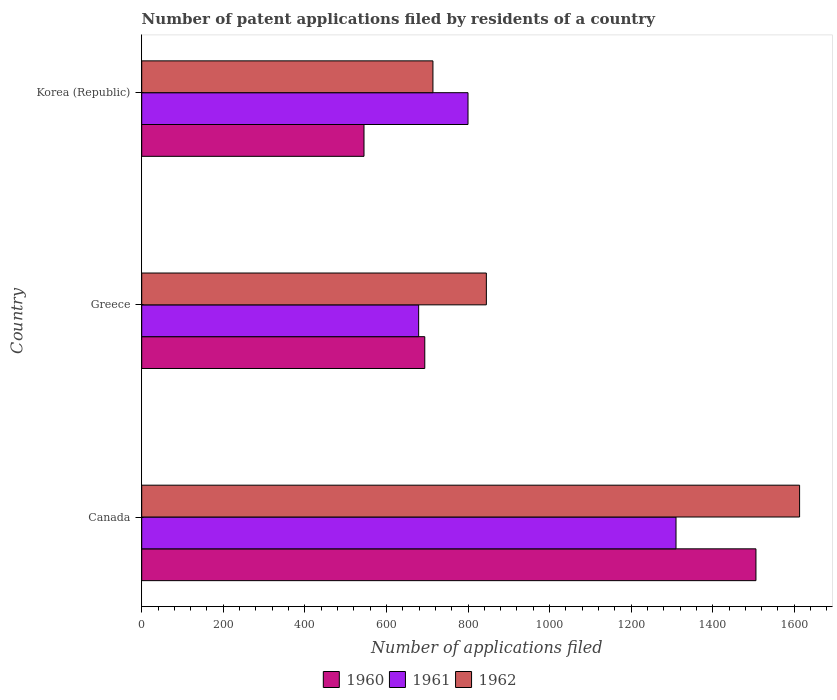How many different coloured bars are there?
Give a very brief answer. 3. How many groups of bars are there?
Your answer should be very brief. 3. Are the number of bars on each tick of the Y-axis equal?
Ensure brevity in your answer.  Yes. How many bars are there on the 2nd tick from the top?
Ensure brevity in your answer.  3. How many bars are there on the 1st tick from the bottom?
Offer a terse response. 3. What is the label of the 3rd group of bars from the top?
Your answer should be compact. Canada. What is the number of applications filed in 1962 in Greece?
Your answer should be very brief. 845. Across all countries, what is the maximum number of applications filed in 1962?
Your response must be concise. 1613. Across all countries, what is the minimum number of applications filed in 1962?
Ensure brevity in your answer.  714. In which country was the number of applications filed in 1960 minimum?
Ensure brevity in your answer.  Korea (Republic). What is the total number of applications filed in 1962 in the graph?
Ensure brevity in your answer.  3172. What is the difference between the number of applications filed in 1962 in Canada and that in Greece?
Your response must be concise. 768. What is the difference between the number of applications filed in 1961 in Greece and the number of applications filed in 1960 in Canada?
Your answer should be compact. -827. What is the average number of applications filed in 1960 per country?
Your answer should be compact. 915. What is the difference between the number of applications filed in 1962 and number of applications filed in 1961 in Korea (Republic)?
Give a very brief answer. -86. What is the ratio of the number of applications filed in 1962 in Canada to that in Greece?
Offer a terse response. 1.91. What is the difference between the highest and the second highest number of applications filed in 1960?
Your response must be concise. 812. What is the difference between the highest and the lowest number of applications filed in 1962?
Make the answer very short. 899. What does the 3rd bar from the top in Canada represents?
Give a very brief answer. 1960. What does the 2nd bar from the bottom in Canada represents?
Provide a short and direct response. 1961. Is it the case that in every country, the sum of the number of applications filed in 1960 and number of applications filed in 1962 is greater than the number of applications filed in 1961?
Provide a short and direct response. Yes. How many countries are there in the graph?
Provide a short and direct response. 3. Does the graph contain any zero values?
Give a very brief answer. No. Does the graph contain grids?
Provide a succinct answer. No. How many legend labels are there?
Offer a terse response. 3. How are the legend labels stacked?
Provide a succinct answer. Horizontal. What is the title of the graph?
Your answer should be compact. Number of patent applications filed by residents of a country. What is the label or title of the X-axis?
Provide a short and direct response. Number of applications filed. What is the Number of applications filed in 1960 in Canada?
Offer a very short reply. 1506. What is the Number of applications filed of 1961 in Canada?
Give a very brief answer. 1310. What is the Number of applications filed in 1962 in Canada?
Offer a terse response. 1613. What is the Number of applications filed of 1960 in Greece?
Your response must be concise. 694. What is the Number of applications filed of 1961 in Greece?
Your answer should be very brief. 679. What is the Number of applications filed of 1962 in Greece?
Provide a succinct answer. 845. What is the Number of applications filed of 1960 in Korea (Republic)?
Offer a terse response. 545. What is the Number of applications filed of 1961 in Korea (Republic)?
Keep it short and to the point. 800. What is the Number of applications filed of 1962 in Korea (Republic)?
Offer a terse response. 714. Across all countries, what is the maximum Number of applications filed of 1960?
Give a very brief answer. 1506. Across all countries, what is the maximum Number of applications filed of 1961?
Your answer should be very brief. 1310. Across all countries, what is the maximum Number of applications filed of 1962?
Offer a very short reply. 1613. Across all countries, what is the minimum Number of applications filed of 1960?
Your answer should be compact. 545. Across all countries, what is the minimum Number of applications filed of 1961?
Provide a short and direct response. 679. Across all countries, what is the minimum Number of applications filed of 1962?
Your response must be concise. 714. What is the total Number of applications filed in 1960 in the graph?
Ensure brevity in your answer.  2745. What is the total Number of applications filed of 1961 in the graph?
Your response must be concise. 2789. What is the total Number of applications filed of 1962 in the graph?
Keep it short and to the point. 3172. What is the difference between the Number of applications filed in 1960 in Canada and that in Greece?
Offer a very short reply. 812. What is the difference between the Number of applications filed of 1961 in Canada and that in Greece?
Offer a very short reply. 631. What is the difference between the Number of applications filed of 1962 in Canada and that in Greece?
Your response must be concise. 768. What is the difference between the Number of applications filed in 1960 in Canada and that in Korea (Republic)?
Offer a terse response. 961. What is the difference between the Number of applications filed in 1961 in Canada and that in Korea (Republic)?
Make the answer very short. 510. What is the difference between the Number of applications filed in 1962 in Canada and that in Korea (Republic)?
Provide a succinct answer. 899. What is the difference between the Number of applications filed of 1960 in Greece and that in Korea (Republic)?
Offer a terse response. 149. What is the difference between the Number of applications filed of 1961 in Greece and that in Korea (Republic)?
Your answer should be compact. -121. What is the difference between the Number of applications filed in 1962 in Greece and that in Korea (Republic)?
Offer a very short reply. 131. What is the difference between the Number of applications filed in 1960 in Canada and the Number of applications filed in 1961 in Greece?
Make the answer very short. 827. What is the difference between the Number of applications filed in 1960 in Canada and the Number of applications filed in 1962 in Greece?
Make the answer very short. 661. What is the difference between the Number of applications filed of 1961 in Canada and the Number of applications filed of 1962 in Greece?
Offer a terse response. 465. What is the difference between the Number of applications filed of 1960 in Canada and the Number of applications filed of 1961 in Korea (Republic)?
Provide a short and direct response. 706. What is the difference between the Number of applications filed of 1960 in Canada and the Number of applications filed of 1962 in Korea (Republic)?
Your answer should be very brief. 792. What is the difference between the Number of applications filed in 1961 in Canada and the Number of applications filed in 1962 in Korea (Republic)?
Your answer should be compact. 596. What is the difference between the Number of applications filed in 1960 in Greece and the Number of applications filed in 1961 in Korea (Republic)?
Your response must be concise. -106. What is the difference between the Number of applications filed of 1960 in Greece and the Number of applications filed of 1962 in Korea (Republic)?
Your answer should be very brief. -20. What is the difference between the Number of applications filed of 1961 in Greece and the Number of applications filed of 1962 in Korea (Republic)?
Keep it short and to the point. -35. What is the average Number of applications filed of 1960 per country?
Provide a succinct answer. 915. What is the average Number of applications filed of 1961 per country?
Your answer should be compact. 929.67. What is the average Number of applications filed in 1962 per country?
Provide a succinct answer. 1057.33. What is the difference between the Number of applications filed of 1960 and Number of applications filed of 1961 in Canada?
Offer a terse response. 196. What is the difference between the Number of applications filed in 1960 and Number of applications filed in 1962 in Canada?
Provide a succinct answer. -107. What is the difference between the Number of applications filed of 1961 and Number of applications filed of 1962 in Canada?
Provide a short and direct response. -303. What is the difference between the Number of applications filed of 1960 and Number of applications filed of 1961 in Greece?
Provide a succinct answer. 15. What is the difference between the Number of applications filed of 1960 and Number of applications filed of 1962 in Greece?
Offer a very short reply. -151. What is the difference between the Number of applications filed of 1961 and Number of applications filed of 1962 in Greece?
Give a very brief answer. -166. What is the difference between the Number of applications filed in 1960 and Number of applications filed in 1961 in Korea (Republic)?
Your response must be concise. -255. What is the difference between the Number of applications filed in 1960 and Number of applications filed in 1962 in Korea (Republic)?
Keep it short and to the point. -169. What is the ratio of the Number of applications filed in 1960 in Canada to that in Greece?
Make the answer very short. 2.17. What is the ratio of the Number of applications filed of 1961 in Canada to that in Greece?
Provide a succinct answer. 1.93. What is the ratio of the Number of applications filed in 1962 in Canada to that in Greece?
Provide a short and direct response. 1.91. What is the ratio of the Number of applications filed in 1960 in Canada to that in Korea (Republic)?
Ensure brevity in your answer.  2.76. What is the ratio of the Number of applications filed of 1961 in Canada to that in Korea (Republic)?
Offer a very short reply. 1.64. What is the ratio of the Number of applications filed in 1962 in Canada to that in Korea (Republic)?
Offer a very short reply. 2.26. What is the ratio of the Number of applications filed of 1960 in Greece to that in Korea (Republic)?
Ensure brevity in your answer.  1.27. What is the ratio of the Number of applications filed of 1961 in Greece to that in Korea (Republic)?
Give a very brief answer. 0.85. What is the ratio of the Number of applications filed of 1962 in Greece to that in Korea (Republic)?
Your answer should be very brief. 1.18. What is the difference between the highest and the second highest Number of applications filed in 1960?
Your response must be concise. 812. What is the difference between the highest and the second highest Number of applications filed in 1961?
Provide a succinct answer. 510. What is the difference between the highest and the second highest Number of applications filed in 1962?
Your answer should be compact. 768. What is the difference between the highest and the lowest Number of applications filed of 1960?
Offer a terse response. 961. What is the difference between the highest and the lowest Number of applications filed in 1961?
Your answer should be compact. 631. What is the difference between the highest and the lowest Number of applications filed of 1962?
Offer a very short reply. 899. 